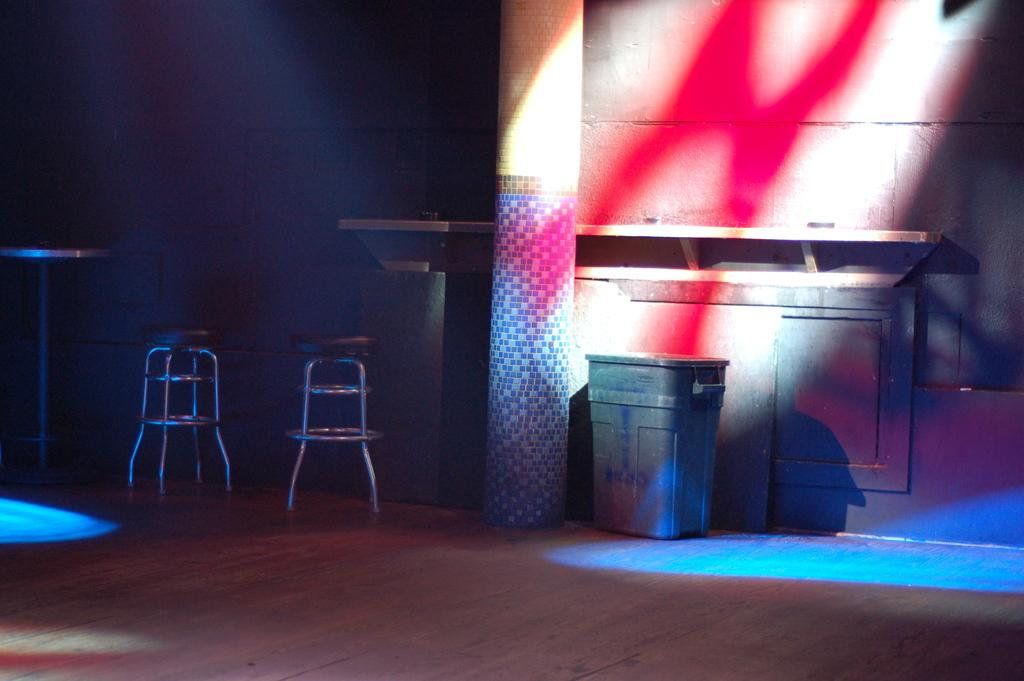How many stools are in the image? There are two stools in the image. What other structures can be seen in the image? There is a pillar and a table in the image. What object might be used for waste disposal in the image? It appears to be a dustbin in the image. What part of the room is visible in the image? The floor is visible in the image. What type of architectural feature is present in the image? There is a wall in the image. What type of corn is growing on the tail of the animal in the image? There is no animal or corn present in the image. What color is the flag flying on the wall in the image? There is no flag present in the image. 